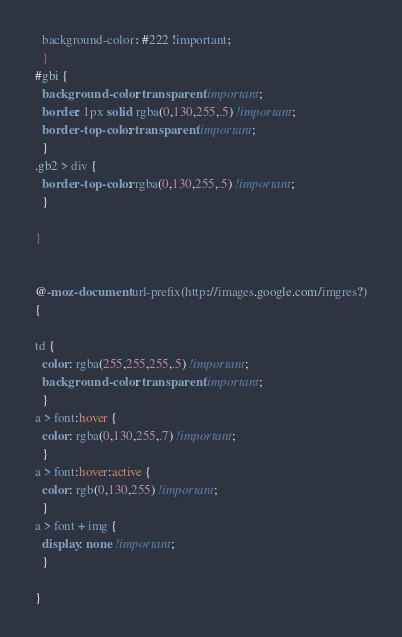Convert code to text. <code><loc_0><loc_0><loc_500><loc_500><_CSS_>  background-color: #222 !important;

  }

#gbi {

  background-color: transparent !important;

  border: 1px solid rgba(0,130,255,.5) !important;

  border-top-color: transparent !important;

  }

.gb2 > div {

  border-top-color: rgba(0,130,255,.5) !important;

  }



}





@-moz-document url-prefix(http://images.google.com/imgres?)

{



td {

  color: rgba(255,255,255,.5) !important;

  background-color: transparent !important;

  }

a > font:hover {

  color: rgba(0,130,255,.7) !important;

  }

a > font:hover:active {

  color: rgb(0,130,255) !important;

  }

a > font + img {

  display: none !important;

  }



}</code> 